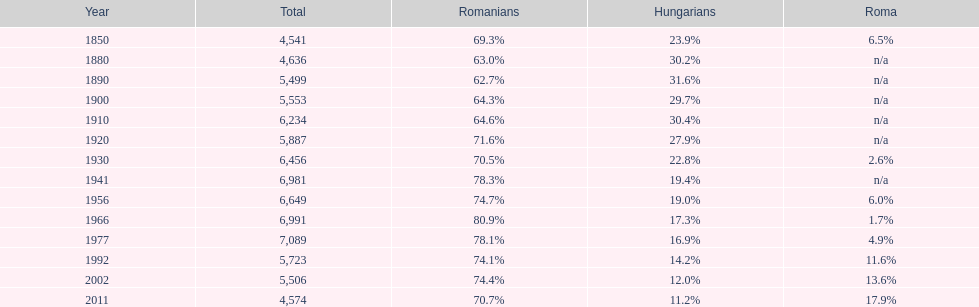In what year was the peak percentage of the romanian population recorded? 1966. 